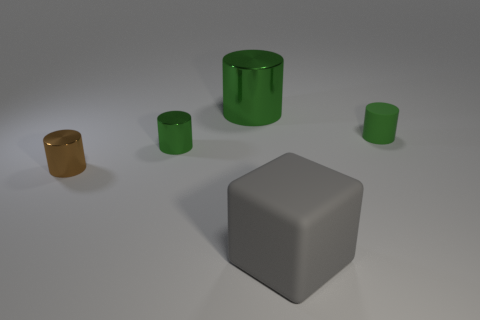Subtract all green cylinders. How many were subtracted if there are1green cylinders left? 2 Add 5 gray things. How many objects exist? 10 Subtract all green cylinders. How many cylinders are left? 1 Subtract all yellow cubes. How many green cylinders are left? 3 Subtract all green cylinders. How many cylinders are left? 1 Subtract 1 cylinders. How many cylinders are left? 3 Add 4 big metallic cylinders. How many big metallic cylinders exist? 5 Subtract 1 green cylinders. How many objects are left? 4 Subtract all cylinders. How many objects are left? 1 Subtract all brown blocks. Subtract all purple cylinders. How many blocks are left? 1 